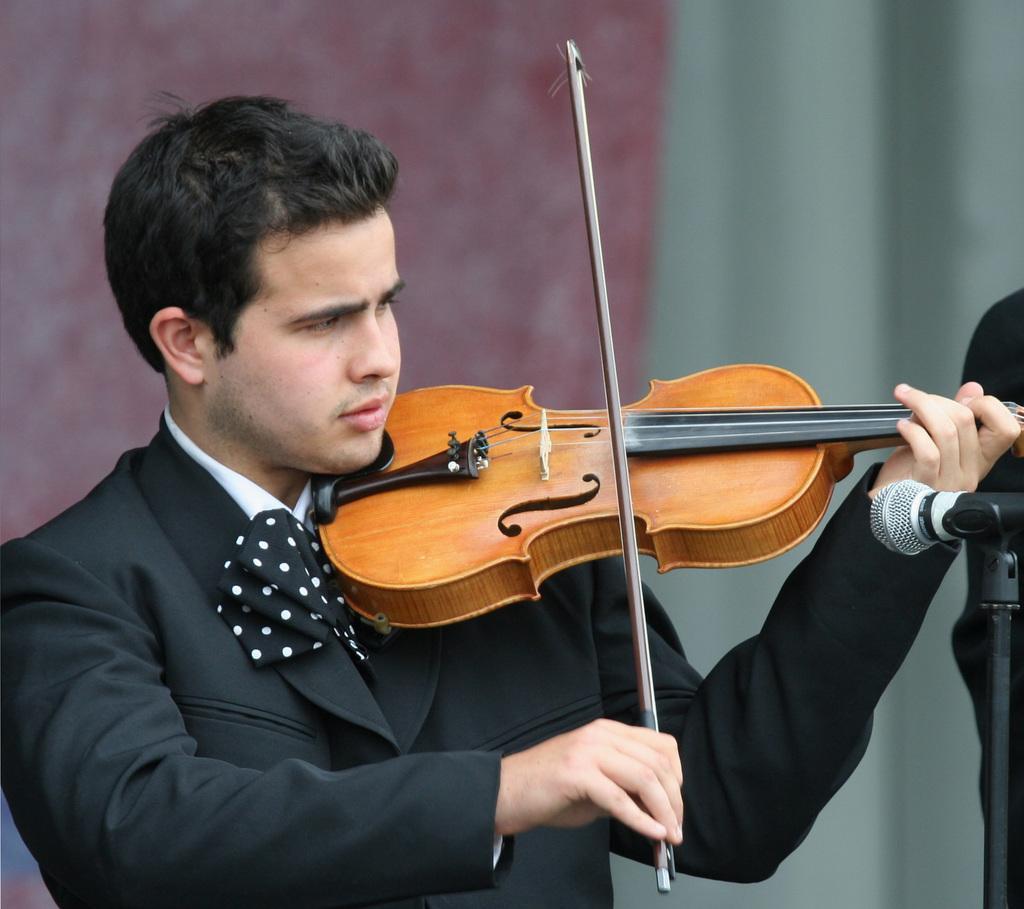Can you describe this image briefly? In this image we can see a man standing and playing a violin. On the right we can see a mic placed on the stand. In the background there is a wall and a curtain. 